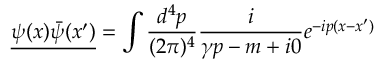<formula> <loc_0><loc_0><loc_500><loc_500>{ \underline { { \psi ( x ) { \bar { \psi } } ( x ^ { \prime } ) } } } = \int { \frac { d ^ { 4 } p } { ( 2 \pi ) ^ { 4 } } } { \frac { i } { \gamma p - m + i 0 } } e ^ { - i p ( x - x ^ { \prime } ) }</formula> 